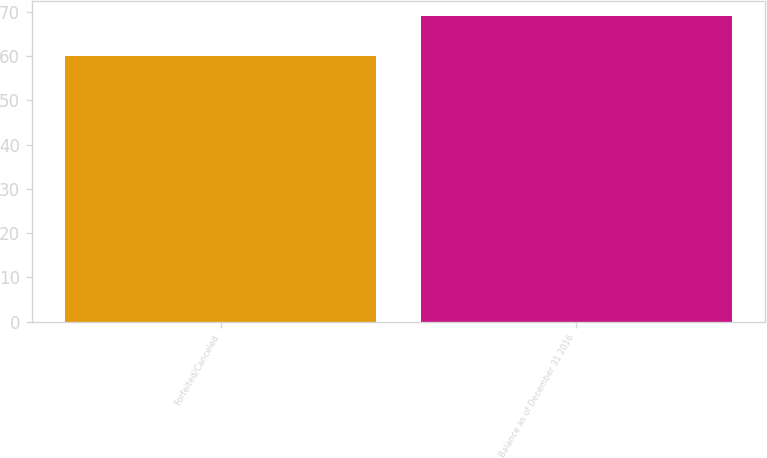<chart> <loc_0><loc_0><loc_500><loc_500><bar_chart><fcel>Forfeited/Canceled<fcel>Balance as of December 31 2016<nl><fcel>60<fcel>69<nl></chart> 